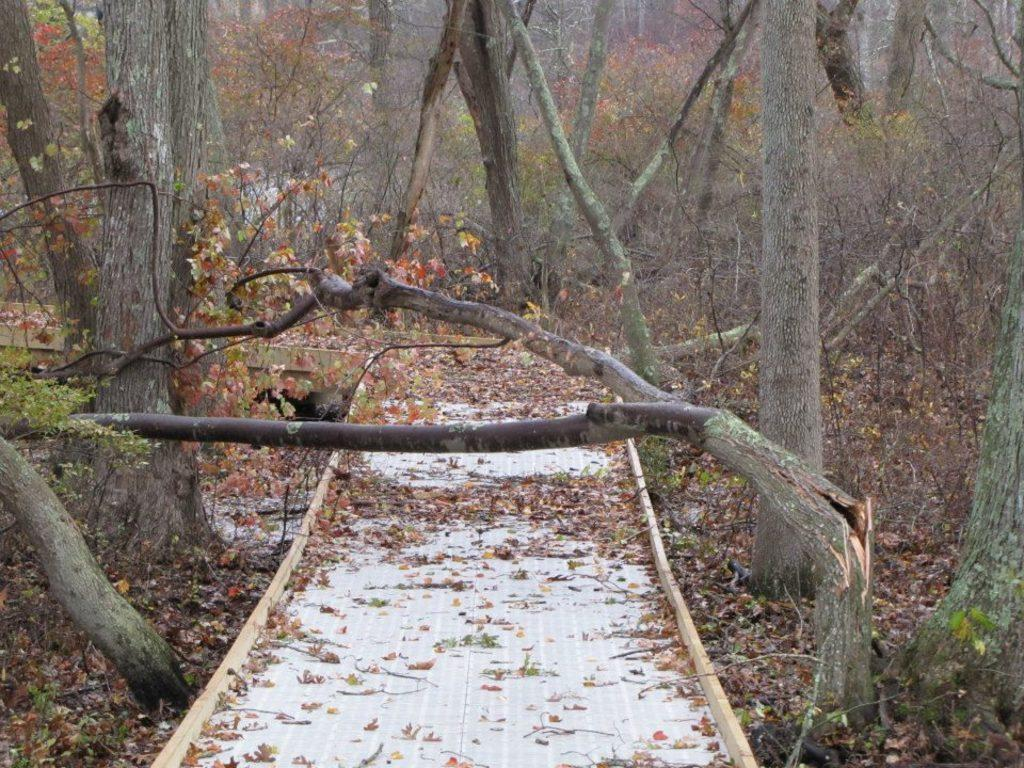What is the main feature in the middle of the image? There is a path in the middle of the image. What can be seen on the path? Leaves are present on the path. What is visible in the background of the image? There are trees in the background of the image. What else can be seen on the ground in the background? Leaves are visible on the ground in the background. What language is spoken by the impulse in the image? There is no impulse present in the image, and therefore no language can be attributed to it. 